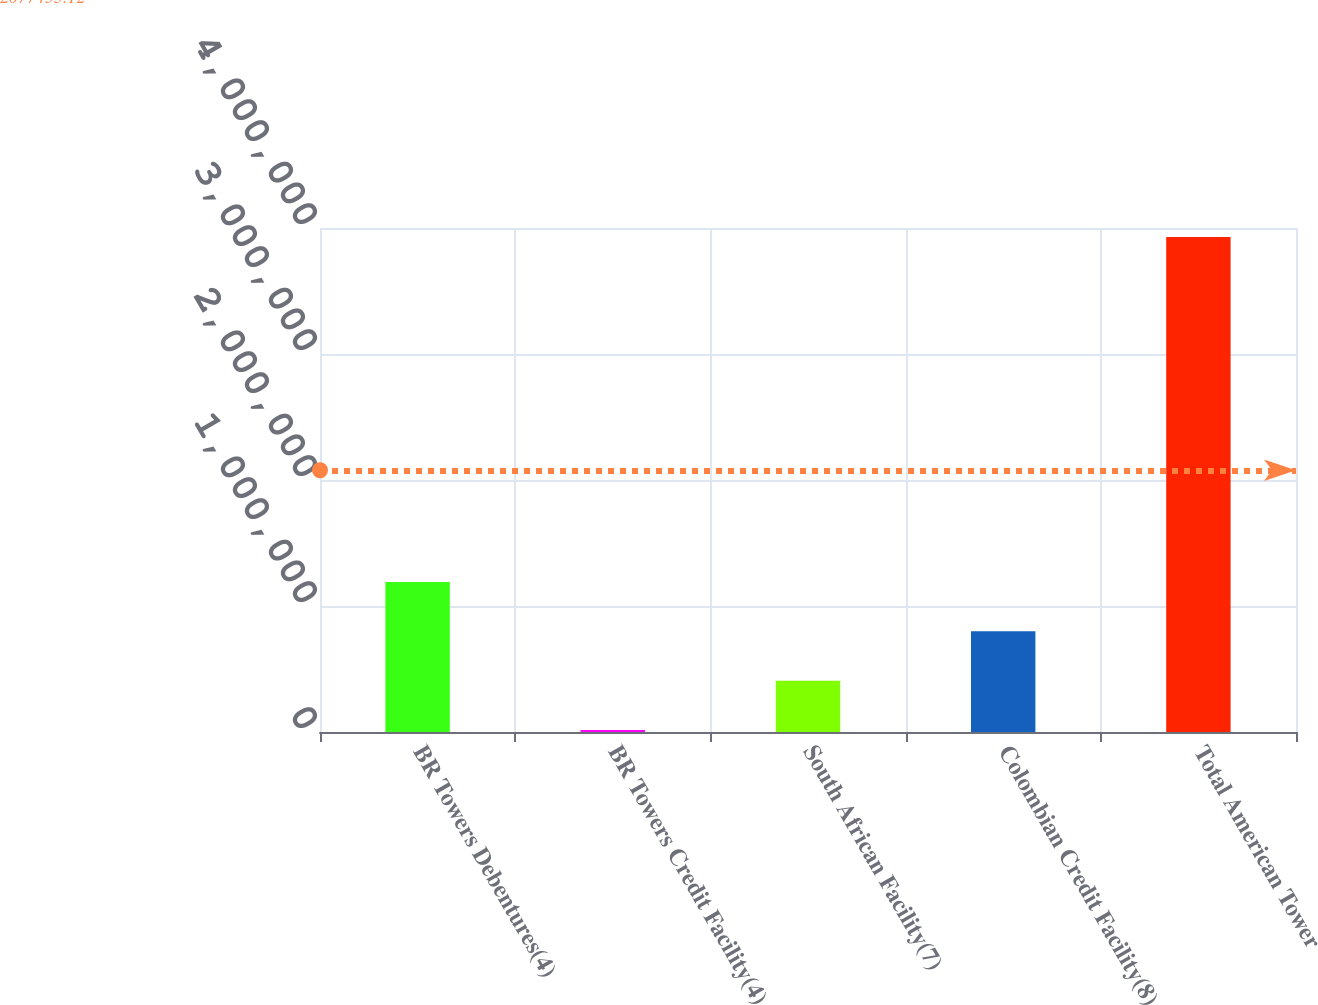<chart> <loc_0><loc_0><loc_500><loc_500><bar_chart><fcel>BR Towers Debentures(4)<fcel>BR Towers Credit Facility(4)<fcel>South African Facility(7)<fcel>Colombian Credit Facility(8)<fcel>Total American Tower<nl><fcel>1.18986e+06<fcel>16389<fcel>407545<fcel>798701<fcel>3.92795e+06<nl></chart> 